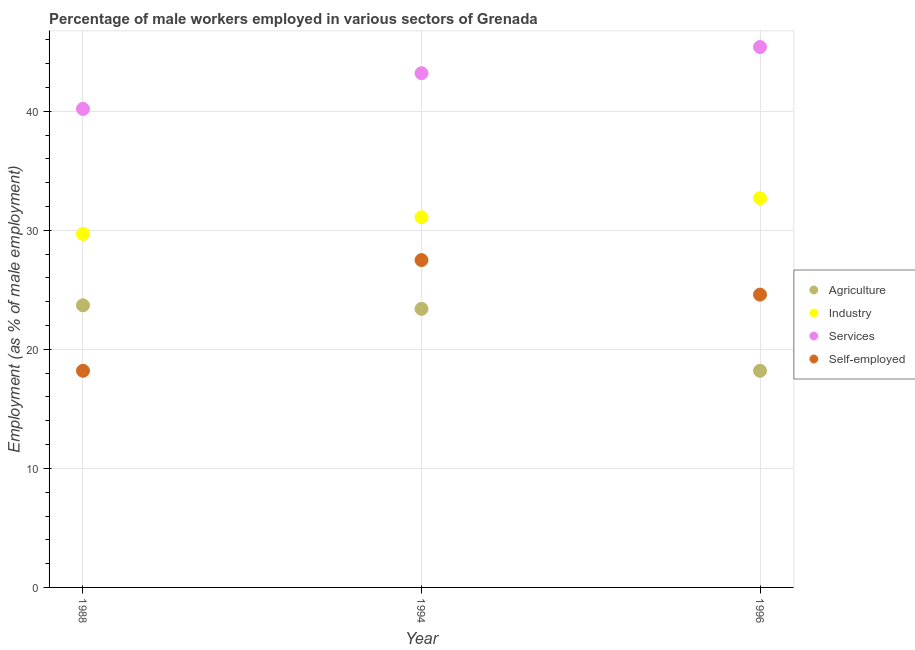How many different coloured dotlines are there?
Offer a very short reply. 4. What is the percentage of male workers in services in 1996?
Offer a very short reply. 45.4. Across all years, what is the maximum percentage of self employed male workers?
Give a very brief answer. 27.5. Across all years, what is the minimum percentage of self employed male workers?
Provide a succinct answer. 18.2. In which year was the percentage of male workers in industry maximum?
Make the answer very short. 1996. In which year was the percentage of male workers in industry minimum?
Provide a short and direct response. 1988. What is the total percentage of self employed male workers in the graph?
Ensure brevity in your answer.  70.3. What is the difference between the percentage of male workers in services in 1988 and that in 1994?
Your answer should be very brief. -3. What is the difference between the percentage of male workers in industry in 1994 and the percentage of self employed male workers in 1996?
Keep it short and to the point. 6.5. What is the average percentage of male workers in industry per year?
Make the answer very short. 31.17. In the year 1988, what is the difference between the percentage of male workers in agriculture and percentage of male workers in services?
Make the answer very short. -16.5. What is the ratio of the percentage of self employed male workers in 1988 to that in 1994?
Make the answer very short. 0.66. Is the difference between the percentage of male workers in services in 1988 and 1994 greater than the difference between the percentage of male workers in agriculture in 1988 and 1994?
Make the answer very short. No. What is the difference between the highest and the second highest percentage of self employed male workers?
Offer a terse response. 2.9. What is the difference between the highest and the lowest percentage of male workers in agriculture?
Provide a short and direct response. 5.5. In how many years, is the percentage of male workers in agriculture greater than the average percentage of male workers in agriculture taken over all years?
Your response must be concise. 2. Is the sum of the percentage of male workers in services in 1988 and 1994 greater than the maximum percentage of male workers in agriculture across all years?
Keep it short and to the point. Yes. Is it the case that in every year, the sum of the percentage of male workers in services and percentage of male workers in agriculture is greater than the sum of percentage of male workers in industry and percentage of self employed male workers?
Keep it short and to the point. Yes. Is it the case that in every year, the sum of the percentage of male workers in agriculture and percentage of male workers in industry is greater than the percentage of male workers in services?
Keep it short and to the point. Yes. Does the percentage of self employed male workers monotonically increase over the years?
Offer a very short reply. No. Is the percentage of male workers in industry strictly greater than the percentage of self employed male workers over the years?
Keep it short and to the point. Yes. How many dotlines are there?
Ensure brevity in your answer.  4. How many years are there in the graph?
Your answer should be compact. 3. What is the difference between two consecutive major ticks on the Y-axis?
Your response must be concise. 10. How many legend labels are there?
Offer a terse response. 4. What is the title of the graph?
Keep it short and to the point. Percentage of male workers employed in various sectors of Grenada. What is the label or title of the Y-axis?
Your answer should be very brief. Employment (as % of male employment). What is the Employment (as % of male employment) of Agriculture in 1988?
Provide a short and direct response. 23.7. What is the Employment (as % of male employment) of Industry in 1988?
Offer a very short reply. 29.7. What is the Employment (as % of male employment) in Services in 1988?
Give a very brief answer. 40.2. What is the Employment (as % of male employment) in Self-employed in 1988?
Give a very brief answer. 18.2. What is the Employment (as % of male employment) in Agriculture in 1994?
Give a very brief answer. 23.4. What is the Employment (as % of male employment) of Industry in 1994?
Keep it short and to the point. 31.1. What is the Employment (as % of male employment) in Services in 1994?
Provide a short and direct response. 43.2. What is the Employment (as % of male employment) of Self-employed in 1994?
Provide a short and direct response. 27.5. What is the Employment (as % of male employment) of Agriculture in 1996?
Ensure brevity in your answer.  18.2. What is the Employment (as % of male employment) of Industry in 1996?
Ensure brevity in your answer.  32.7. What is the Employment (as % of male employment) in Services in 1996?
Give a very brief answer. 45.4. What is the Employment (as % of male employment) in Self-employed in 1996?
Give a very brief answer. 24.6. Across all years, what is the maximum Employment (as % of male employment) in Agriculture?
Provide a short and direct response. 23.7. Across all years, what is the maximum Employment (as % of male employment) of Industry?
Make the answer very short. 32.7. Across all years, what is the maximum Employment (as % of male employment) in Services?
Make the answer very short. 45.4. Across all years, what is the minimum Employment (as % of male employment) in Agriculture?
Offer a very short reply. 18.2. Across all years, what is the minimum Employment (as % of male employment) of Industry?
Provide a succinct answer. 29.7. Across all years, what is the minimum Employment (as % of male employment) of Services?
Your response must be concise. 40.2. Across all years, what is the minimum Employment (as % of male employment) of Self-employed?
Offer a very short reply. 18.2. What is the total Employment (as % of male employment) of Agriculture in the graph?
Your answer should be compact. 65.3. What is the total Employment (as % of male employment) of Industry in the graph?
Make the answer very short. 93.5. What is the total Employment (as % of male employment) in Services in the graph?
Provide a short and direct response. 128.8. What is the total Employment (as % of male employment) of Self-employed in the graph?
Ensure brevity in your answer.  70.3. What is the difference between the Employment (as % of male employment) in Agriculture in 1988 and that in 1994?
Keep it short and to the point. 0.3. What is the difference between the Employment (as % of male employment) in Services in 1988 and that in 1994?
Make the answer very short. -3. What is the difference between the Employment (as % of male employment) in Self-employed in 1988 and that in 1994?
Make the answer very short. -9.3. What is the difference between the Employment (as % of male employment) of Agriculture in 1988 and that in 1996?
Your response must be concise. 5.5. What is the difference between the Employment (as % of male employment) of Services in 1988 and that in 1996?
Your response must be concise. -5.2. What is the difference between the Employment (as % of male employment) of Agriculture in 1994 and that in 1996?
Provide a short and direct response. 5.2. What is the difference between the Employment (as % of male employment) of Services in 1994 and that in 1996?
Your answer should be compact. -2.2. What is the difference between the Employment (as % of male employment) in Self-employed in 1994 and that in 1996?
Offer a terse response. 2.9. What is the difference between the Employment (as % of male employment) of Agriculture in 1988 and the Employment (as % of male employment) of Services in 1994?
Your response must be concise. -19.5. What is the difference between the Employment (as % of male employment) in Agriculture in 1988 and the Employment (as % of male employment) in Self-employed in 1994?
Provide a succinct answer. -3.8. What is the difference between the Employment (as % of male employment) in Services in 1988 and the Employment (as % of male employment) in Self-employed in 1994?
Provide a succinct answer. 12.7. What is the difference between the Employment (as % of male employment) in Agriculture in 1988 and the Employment (as % of male employment) in Industry in 1996?
Provide a short and direct response. -9. What is the difference between the Employment (as % of male employment) in Agriculture in 1988 and the Employment (as % of male employment) in Services in 1996?
Give a very brief answer. -21.7. What is the difference between the Employment (as % of male employment) of Industry in 1988 and the Employment (as % of male employment) of Services in 1996?
Your answer should be very brief. -15.7. What is the difference between the Employment (as % of male employment) in Industry in 1994 and the Employment (as % of male employment) in Services in 1996?
Offer a terse response. -14.3. What is the difference between the Employment (as % of male employment) in Industry in 1994 and the Employment (as % of male employment) in Self-employed in 1996?
Keep it short and to the point. 6.5. What is the difference between the Employment (as % of male employment) in Services in 1994 and the Employment (as % of male employment) in Self-employed in 1996?
Your response must be concise. 18.6. What is the average Employment (as % of male employment) in Agriculture per year?
Your response must be concise. 21.77. What is the average Employment (as % of male employment) in Industry per year?
Ensure brevity in your answer.  31.17. What is the average Employment (as % of male employment) in Services per year?
Your response must be concise. 42.93. What is the average Employment (as % of male employment) of Self-employed per year?
Provide a short and direct response. 23.43. In the year 1988, what is the difference between the Employment (as % of male employment) of Agriculture and Employment (as % of male employment) of Industry?
Your answer should be very brief. -6. In the year 1988, what is the difference between the Employment (as % of male employment) of Agriculture and Employment (as % of male employment) of Services?
Your response must be concise. -16.5. In the year 1994, what is the difference between the Employment (as % of male employment) in Agriculture and Employment (as % of male employment) in Industry?
Keep it short and to the point. -7.7. In the year 1994, what is the difference between the Employment (as % of male employment) of Agriculture and Employment (as % of male employment) of Services?
Offer a terse response. -19.8. In the year 1994, what is the difference between the Employment (as % of male employment) of Agriculture and Employment (as % of male employment) of Self-employed?
Offer a very short reply. -4.1. In the year 1994, what is the difference between the Employment (as % of male employment) in Industry and Employment (as % of male employment) in Self-employed?
Your answer should be very brief. 3.6. In the year 1994, what is the difference between the Employment (as % of male employment) of Services and Employment (as % of male employment) of Self-employed?
Make the answer very short. 15.7. In the year 1996, what is the difference between the Employment (as % of male employment) in Agriculture and Employment (as % of male employment) in Industry?
Your answer should be very brief. -14.5. In the year 1996, what is the difference between the Employment (as % of male employment) in Agriculture and Employment (as % of male employment) in Services?
Ensure brevity in your answer.  -27.2. In the year 1996, what is the difference between the Employment (as % of male employment) in Industry and Employment (as % of male employment) in Services?
Your answer should be compact. -12.7. In the year 1996, what is the difference between the Employment (as % of male employment) of Services and Employment (as % of male employment) of Self-employed?
Provide a short and direct response. 20.8. What is the ratio of the Employment (as % of male employment) in Agriculture in 1988 to that in 1994?
Provide a short and direct response. 1.01. What is the ratio of the Employment (as % of male employment) of Industry in 1988 to that in 1994?
Offer a terse response. 0.95. What is the ratio of the Employment (as % of male employment) in Services in 1988 to that in 1994?
Keep it short and to the point. 0.93. What is the ratio of the Employment (as % of male employment) of Self-employed in 1988 to that in 1994?
Keep it short and to the point. 0.66. What is the ratio of the Employment (as % of male employment) in Agriculture in 1988 to that in 1996?
Give a very brief answer. 1.3. What is the ratio of the Employment (as % of male employment) in Industry in 1988 to that in 1996?
Your response must be concise. 0.91. What is the ratio of the Employment (as % of male employment) of Services in 1988 to that in 1996?
Offer a terse response. 0.89. What is the ratio of the Employment (as % of male employment) of Self-employed in 1988 to that in 1996?
Your answer should be very brief. 0.74. What is the ratio of the Employment (as % of male employment) of Industry in 1994 to that in 1996?
Provide a short and direct response. 0.95. What is the ratio of the Employment (as % of male employment) in Services in 1994 to that in 1996?
Provide a short and direct response. 0.95. What is the ratio of the Employment (as % of male employment) in Self-employed in 1994 to that in 1996?
Make the answer very short. 1.12. What is the difference between the highest and the second highest Employment (as % of male employment) of Industry?
Ensure brevity in your answer.  1.6. What is the difference between the highest and the second highest Employment (as % of male employment) of Services?
Give a very brief answer. 2.2. What is the difference between the highest and the second highest Employment (as % of male employment) in Self-employed?
Provide a short and direct response. 2.9. What is the difference between the highest and the lowest Employment (as % of male employment) in Industry?
Make the answer very short. 3. What is the difference between the highest and the lowest Employment (as % of male employment) in Services?
Provide a succinct answer. 5.2. What is the difference between the highest and the lowest Employment (as % of male employment) of Self-employed?
Provide a short and direct response. 9.3. 